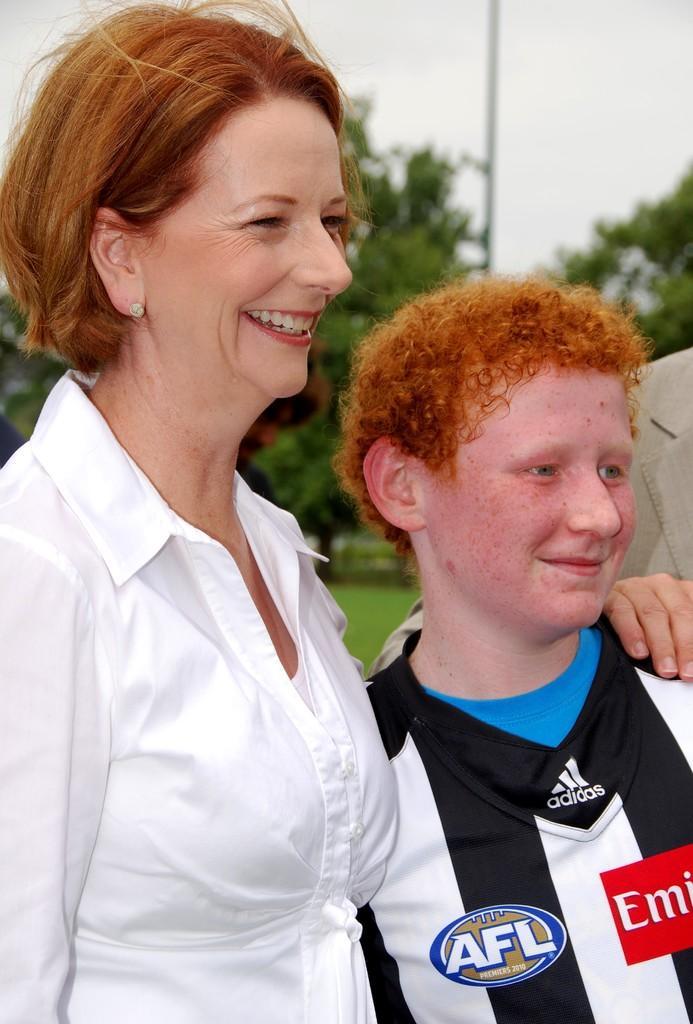In one or two sentences, can you explain what this image depicts? Here I can see two person facing towards the right side and smiling. On the right side there is another person. In the background there are some trees. At the top of the image I can see the sky. 